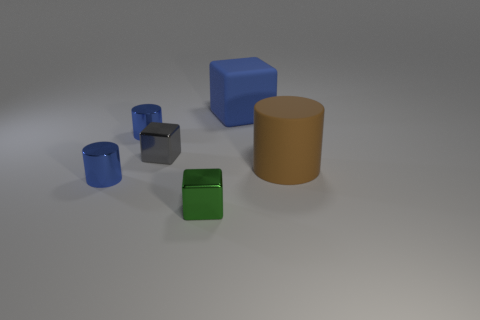There is a tiny shiny block behind the small green shiny thing; what number of small cylinders are in front of it?
Your response must be concise. 1. There is a tiny shiny thing that is to the right of the gray block; does it have the same color as the large block?
Your answer should be compact. No. There is a blue cylinder that is behind the cylinder right of the green cube; is there a cylinder that is on the right side of it?
Your response must be concise. Yes. The thing that is both behind the tiny green metal cube and in front of the big brown matte object has what shape?
Give a very brief answer. Cylinder. Are there any matte things that have the same color as the big block?
Your response must be concise. No. What is the color of the metallic cylinder that is in front of the cylinder that is on the right side of the large blue matte thing?
Make the answer very short. Blue. There is a block behind the tiny shiny block to the left of the green block to the left of the blue matte thing; how big is it?
Give a very brief answer. Large. Does the brown object have the same material as the tiny cube behind the green object?
Offer a very short reply. No. What is the size of the block that is made of the same material as the large brown cylinder?
Your answer should be very brief. Large. Is there a tiny purple matte thing of the same shape as the blue rubber thing?
Give a very brief answer. No. 